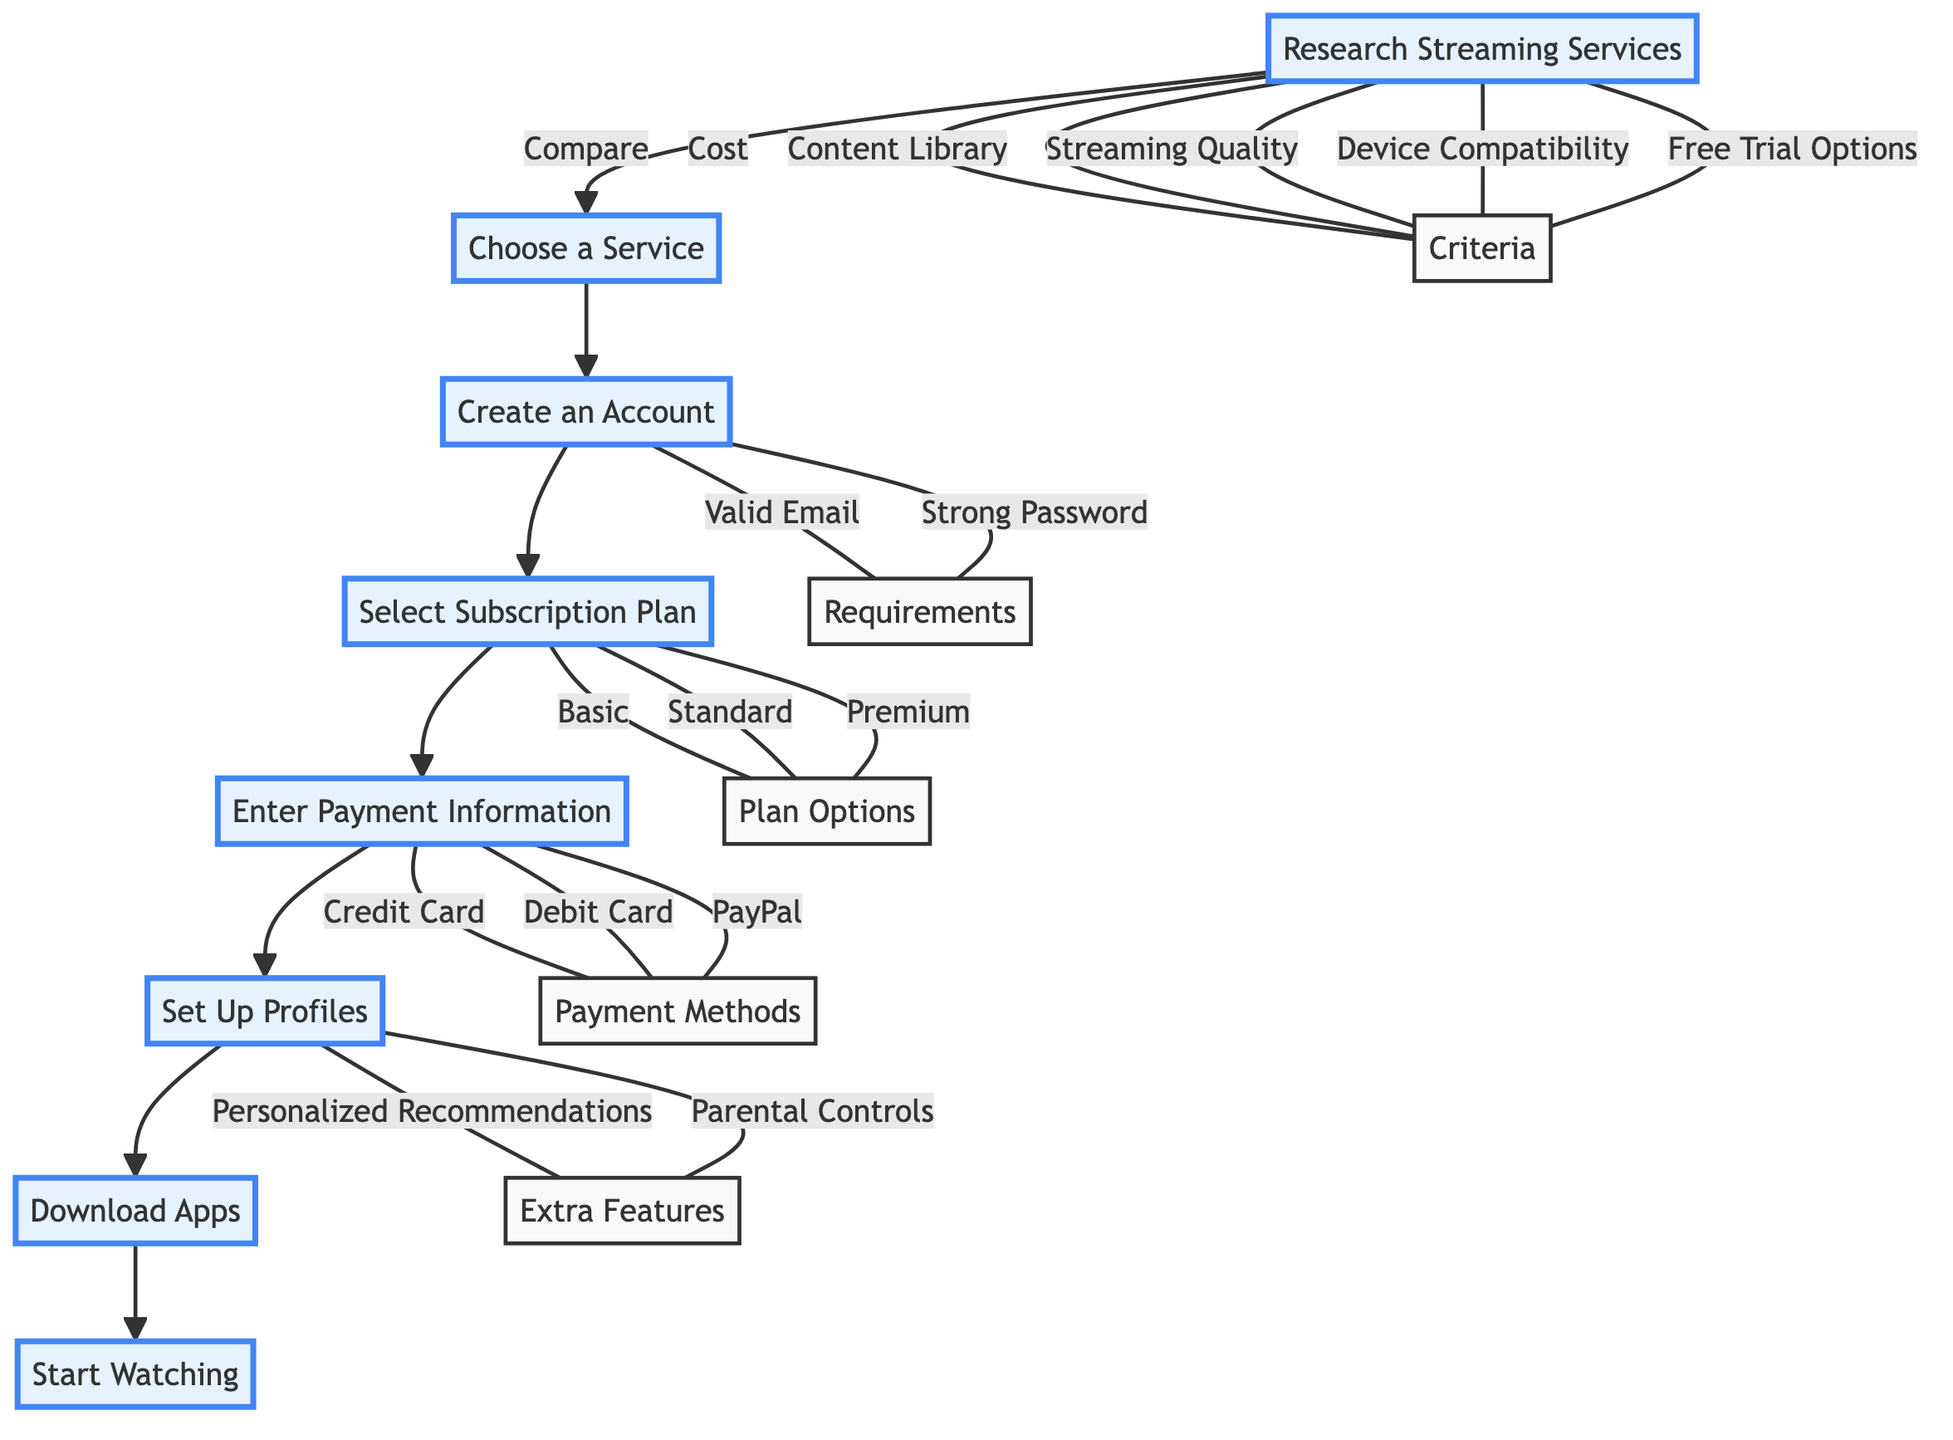What is the first step in setting up a streaming subscription service? The first step indicated in the diagram is "Research Streaming Services," which is represented as node A.
Answer: Research Streaming Services How many subscription plan options are available? According to the diagram, node D presents three plan options: Basic, Standard, and Premium. Therefore, the total number of options is three.
Answer: 3 What do you need to create an account? The requirements listed for creating an account in node C include a valid email address and a strong password. The diagram indicates that these are the two necessary requirements.
Answer: Valid Email Address, Strong Password Which step comes after selecting a subscription plan? Following the flow in the diagram, after selecting a subscription plan at node D, the next step is to "Enter Payment Information" at node E.
Answer: Enter Payment Information What types of payment methods can be used? Node E outlines three payment methods that can be provided: Credit Card, Debit Card, and PayPal. Thus, there are three listed payment method options.
Answer: Credit Card, Debit Card, PayPal What are two extra features that can be set up in profiles? The diagram indicates that under node F, the extra features that can be set up include Personalized Recommendations and Parental Controls. Therefore, two specific features mentioned are these.
Answer: Personalized Recommendations, Parental Controls How is the flow of the process structured? The diagram displays a linear flow where each step leads to the next, starting from Research Streaming Services, followed by Choosing a Service, and so forth until Start Watching, indicating a sequential process.
Answer: Sequential Process What is the last step to take in the streaming setup process? The final node in the flowchart, node H, represents the last step, which is "Start Watching." This indicates that after completing all prior steps, the user begins watching content.
Answer: Start Watching 